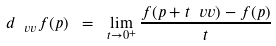Convert formula to latex. <formula><loc_0><loc_0><loc_500><loc_500>d _ { \ v v } f ( p ) \ = \ \lim _ { t \rightarrow 0 ^ { + } } \frac { f ( p + t \ v v ) - f ( p ) } { t }</formula> 